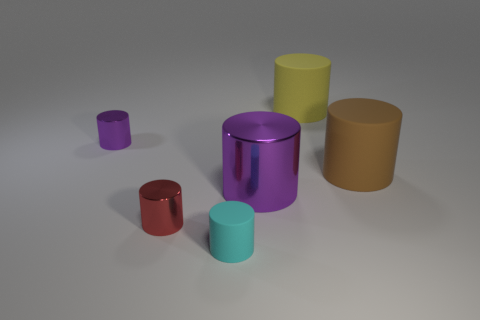Subtract all yellow rubber cylinders. How many cylinders are left? 5 Subtract all brown balls. How many purple cylinders are left? 2 Subtract all cyan cylinders. How many cylinders are left? 5 Add 1 purple metal objects. How many objects exist? 7 Subtract 1 cylinders. How many cylinders are left? 5 Subtract all purple cylinders. Subtract all red balls. How many cylinders are left? 4 Add 6 tiny gray cylinders. How many tiny gray cylinders exist? 6 Subtract 0 blue balls. How many objects are left? 6 Subtract all brown matte things. Subtract all big brown objects. How many objects are left? 4 Add 6 small metal cylinders. How many small metal cylinders are left? 8 